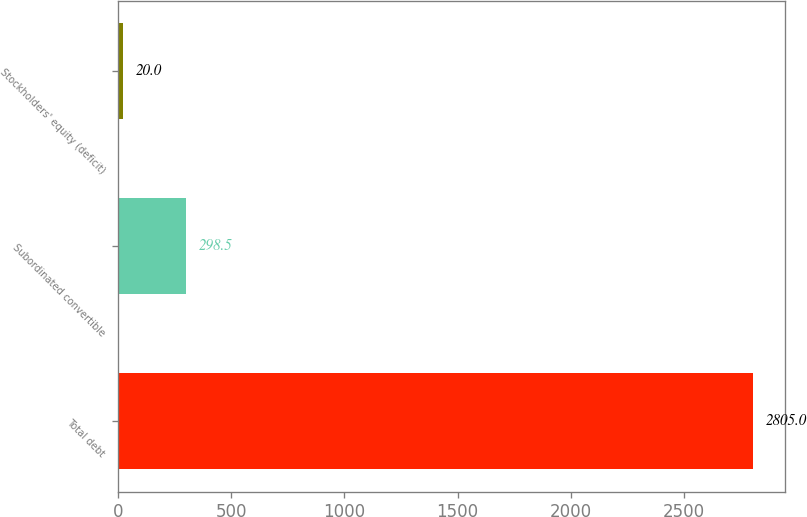Convert chart to OTSL. <chart><loc_0><loc_0><loc_500><loc_500><bar_chart><fcel>Total debt<fcel>Subordinated convertible<fcel>Stockholders' equity (deficit)<nl><fcel>2805<fcel>298.5<fcel>20<nl></chart> 